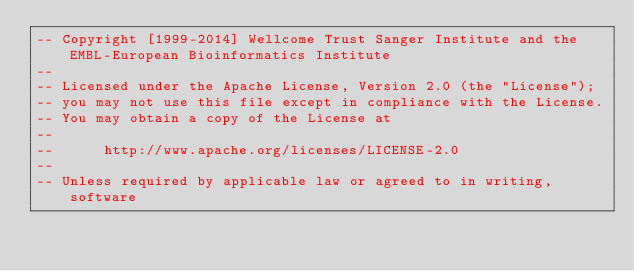<code> <loc_0><loc_0><loc_500><loc_500><_SQL_>-- Copyright [1999-2014] Wellcome Trust Sanger Institute and the EMBL-European Bioinformatics Institute
-- 
-- Licensed under the Apache License, Version 2.0 (the "License");
-- you may not use this file except in compliance with the License.
-- You may obtain a copy of the License at
-- 
--      http://www.apache.org/licenses/LICENSE-2.0
-- 
-- Unless required by applicable law or agreed to in writing, software</code> 